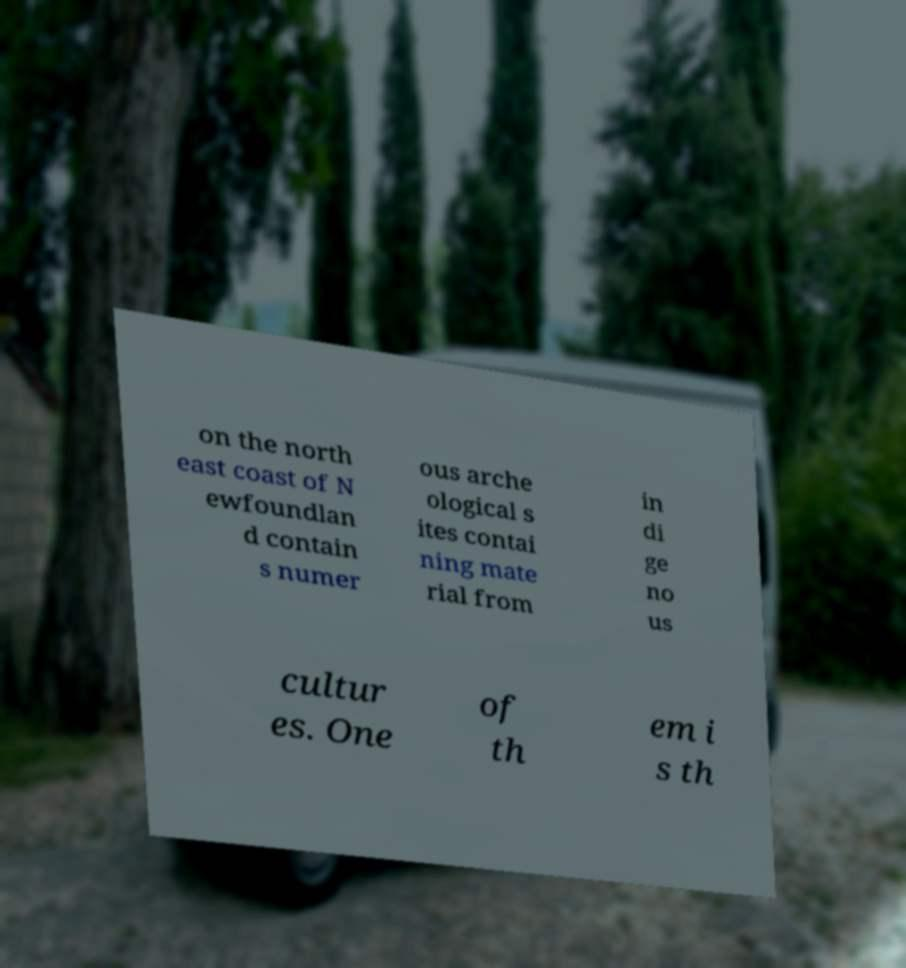Could you assist in decoding the text presented in this image and type it out clearly? on the north east coast of N ewfoundlan d contain s numer ous arche ological s ites contai ning mate rial from in di ge no us cultur es. One of th em i s th 